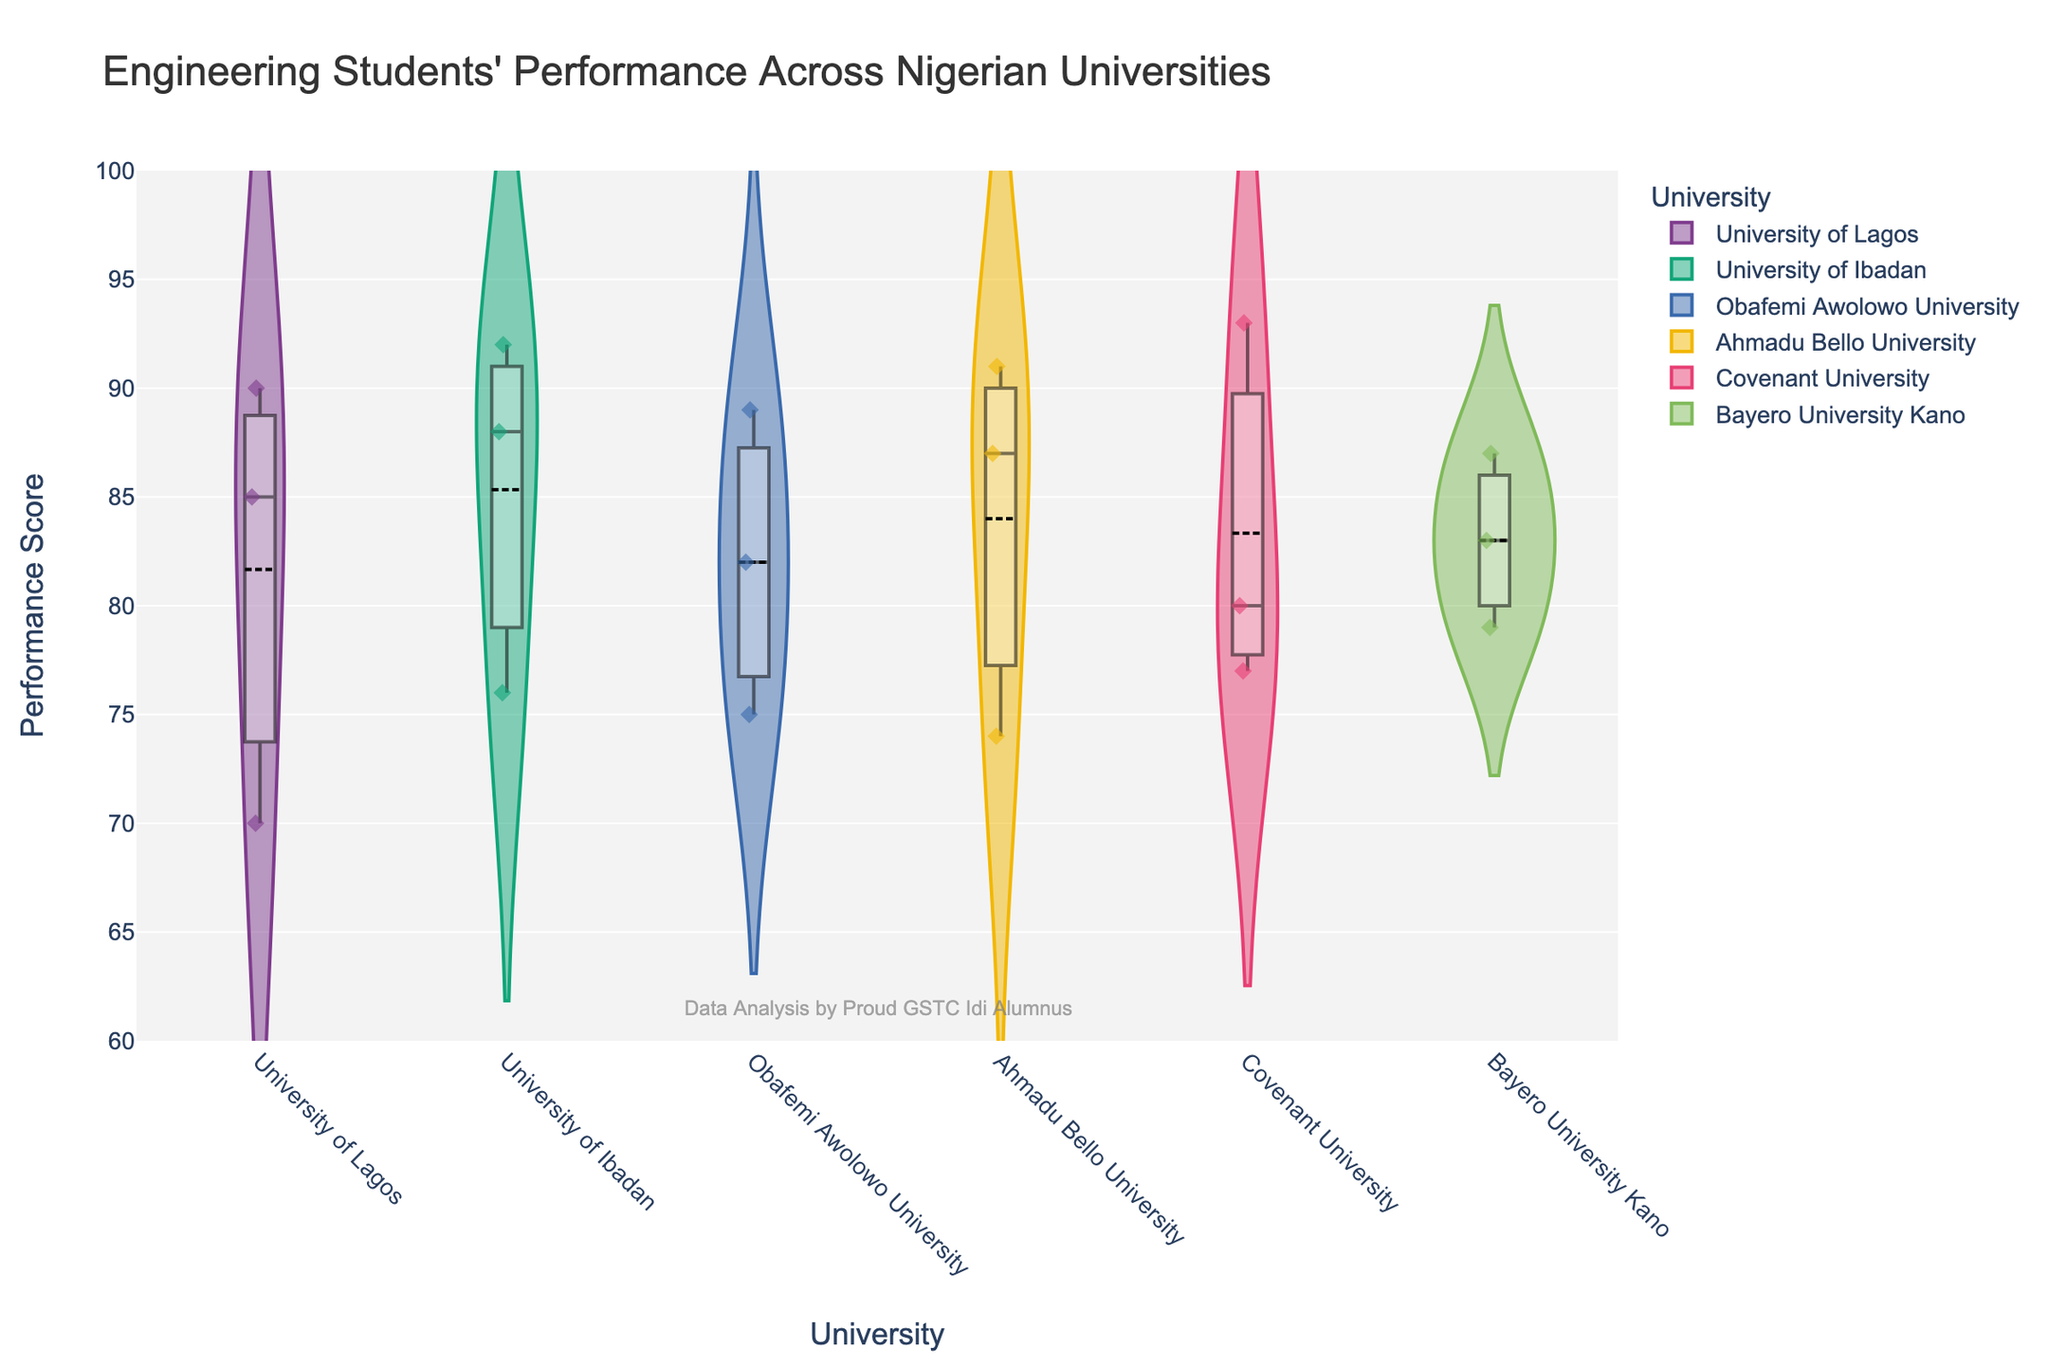What is the title of the violin chart? The title is usually found at the top of the chart. In this case, the title clearly states the focus of the data visualization.
Answer: Engineering Students' Performance Across Nigerian Universities How many universities are included in the violin chart? Count the number of distinct categories along the x-axis, each representing a different university.
Answer: 6 What is the range of the y-axis? The range of the y-axis is indicated by the axis labels and ticks and shows the span of performance scores.
Answer: 60 to 100 Which university has the highest median performance score? Locate the boxes within each violin plot. The line in the middle of the box represents the median. Compare the median lines across all universities to determine the highest one.
Answer: Covenant University What is the interquartile range (IQR) for the University of Lagos? The IQR can be visualized from the box plot within the violin chart. The box represents the middle 50% of the data. Measure the distance between the top (Q3) and bottom (Q1) of the box for the University of Lagos.
Answer: Approx. 15 Which university has the widest spread of performance scores? Examine the width of the violin plots. The width indicates the density and spread of the data points. The wider the plot, the more varied are the scores.
Answer: University of Lagos Are there any outliers in the performance scores for Ahmadu Bello University? Outliers in a violin plot are often represented by individual points outside the main body of the plot. Check for any such points in Ahmadu Bello University's plot.
Answer: No What is the mean performance score for students at Obafemi Awolowo University? The mean is indicated by a line within the violin plot. Locate the mean line for Obafemi Awolowo University to determine the average performance score.
Answer: 82 Compare the mean performance scores of Bayero University Kano and University of Ibadan. Which one is higher? Locate the mean lines in the violin plots for both universities and compare their heights on the y-axis.
Answer: University of Ibadan What is a noticeable trend in the distribution of performance scores across these universities? Observe the overall shape and spread of the violin plots as well as the position of the boxes within them. Identify any common patterns or significant differences in the distributions.
Answer: Most universities have a median around 85-90 with varying spreads 